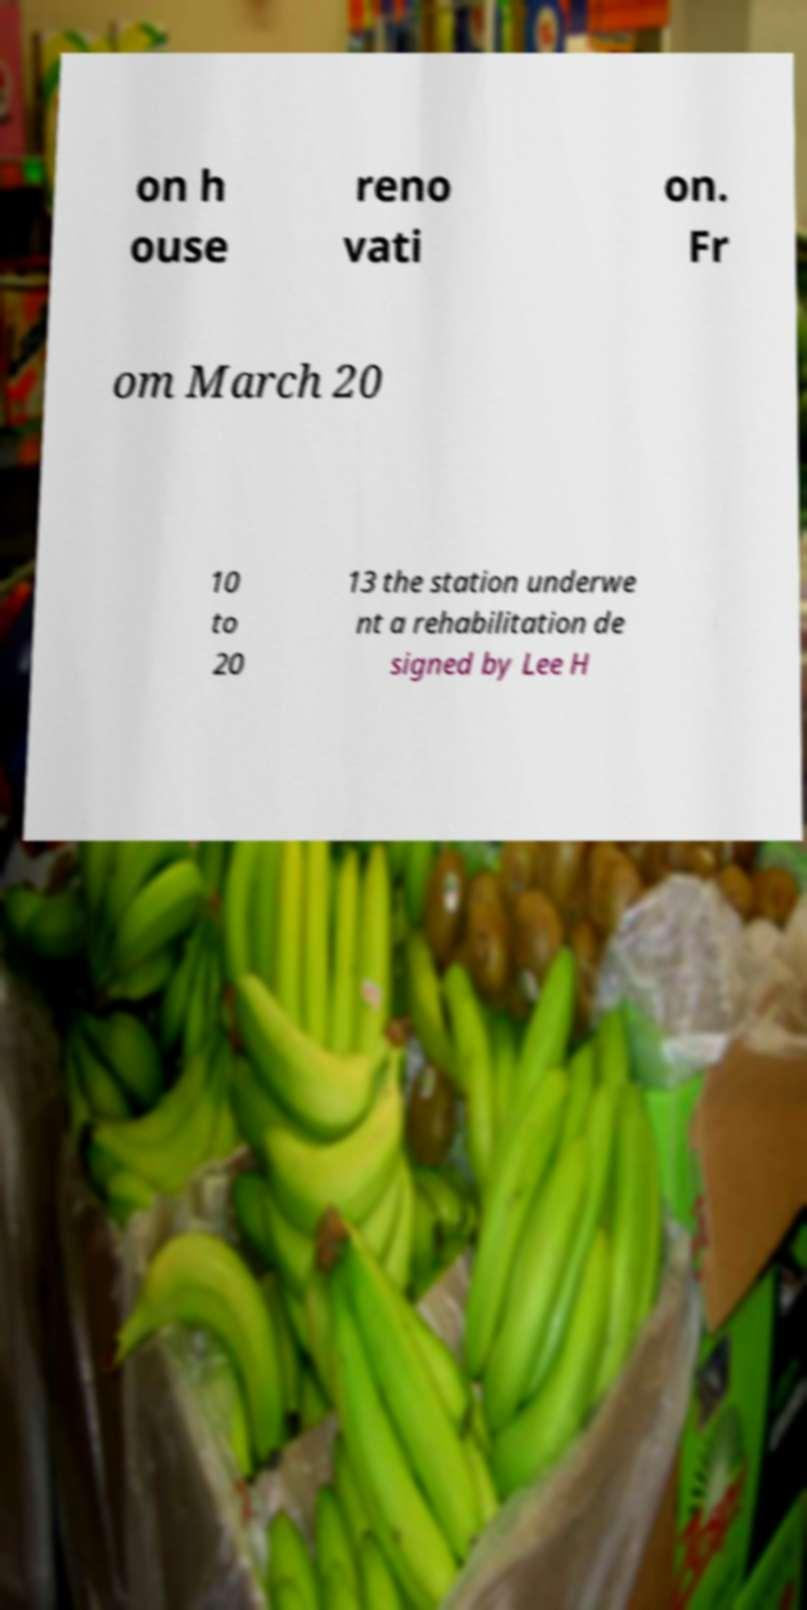Please read and relay the text visible in this image. What does it say? on h ouse reno vati on. Fr om March 20 10 to 20 13 the station underwe nt a rehabilitation de signed by Lee H 